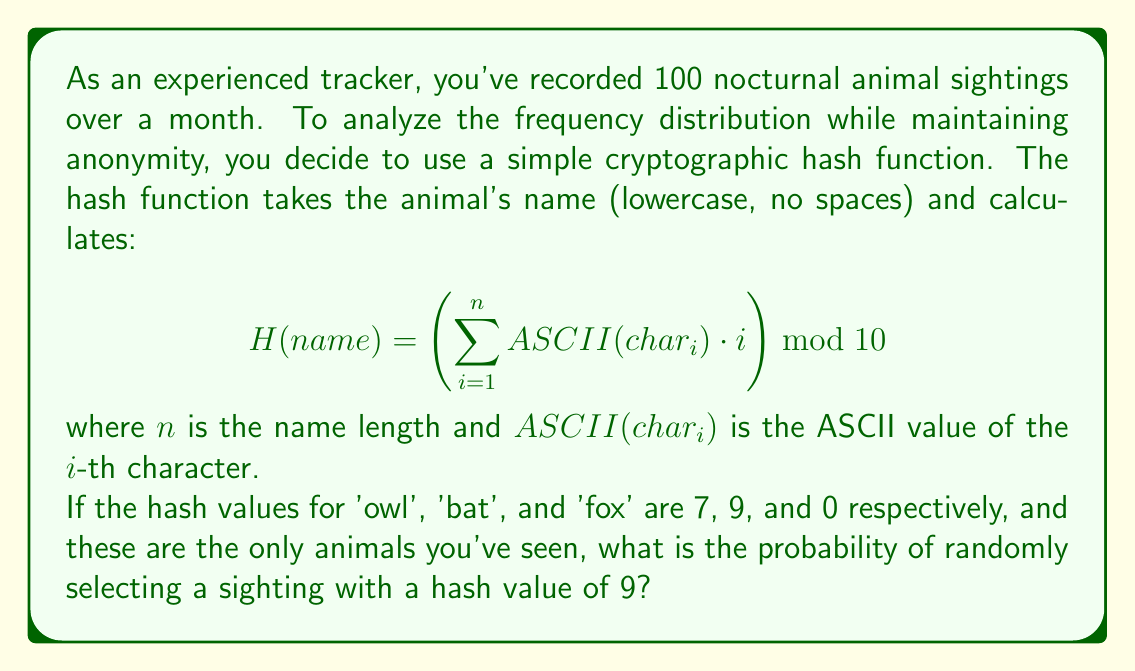Can you answer this question? Let's approach this step-by-step:

1) First, we need to verify the hash values for each animal:

   For 'owl':
   $$ H(owl) = (111 \cdot 1 + 119 \cdot 2 + 108 \cdot 3) \bmod 10 = 667 \bmod 10 = 7 $$

   For 'bat':
   $$ H(bat) = (98 \cdot 1 + 97 \cdot 2 + 116 \cdot 3) \bmod 10 = 639 \bmod 10 = 9 $$

   For 'fox':
   $$ H(fox) = (102 \cdot 1 + 111 \cdot 2 + 120 \cdot 3) \bmod 10 = 680 \bmod 10 = 0 $$

2) Now that we've confirmed the hash values, we know that only 'bat' sightings will have a hash value of 9.

3) To find the probability, we need to know how many 'bat' sightings there were out of the total 100 sightings.

4) However, we don't have this information directly. What we do know is that there are only three types of animals, and the total sightings are 100.

5) In cryptography, when we don't have specific frequency information, we often assume a uniform distribution. This means we assume each animal is equally likely to be seen.

6) With 3 animals and 100 sightings, assuming uniform distribution, we can estimate:
   - Owl sightings: $\approx 33$
   - Bat sightings: $\approx 33$
   - Fox sightings: $\approx 34$ (to make the total 100)

7) Therefore, the probability of randomly selecting a sighting with a hash value of 9 (which corresponds to a bat sighting) is approximately:

   $$ P(H = 9) \approx \frac{33}{100} = 0.33 $$
Answer: 0.33 